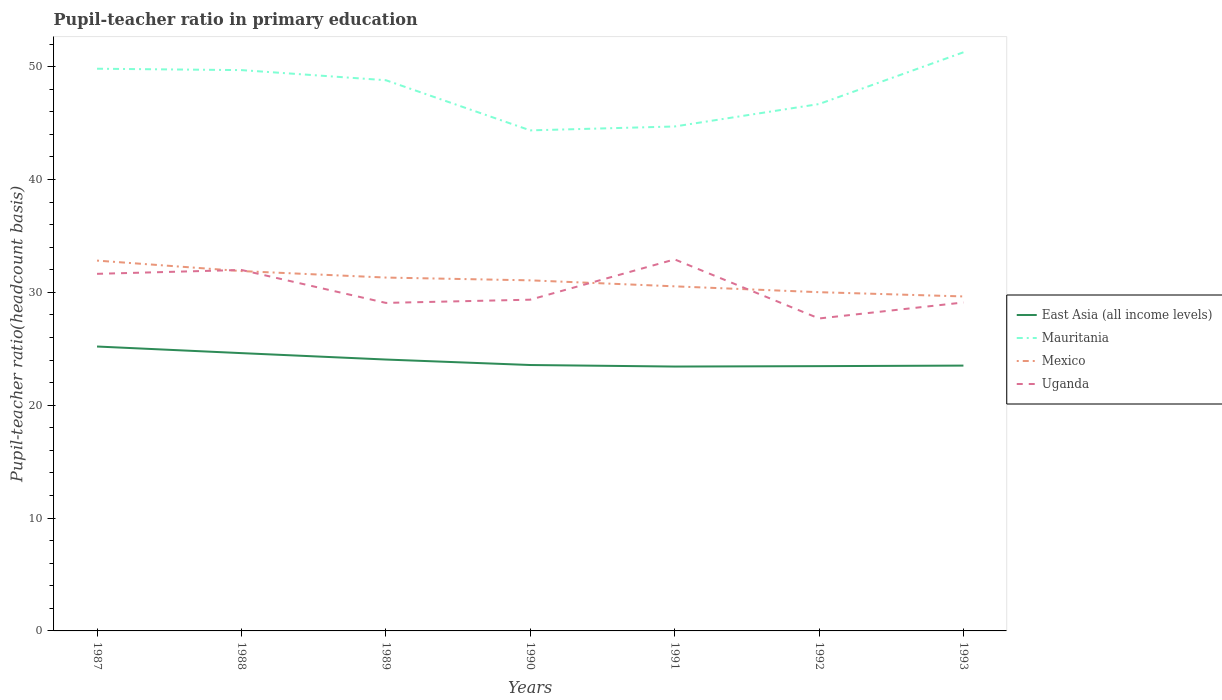How many different coloured lines are there?
Ensure brevity in your answer.  4. Is the number of lines equal to the number of legend labels?
Ensure brevity in your answer.  Yes. Across all years, what is the maximum pupil-teacher ratio in primary education in Mexico?
Provide a short and direct response. 29.64. In which year was the pupil-teacher ratio in primary education in Mexico maximum?
Your response must be concise. 1993. What is the total pupil-teacher ratio in primary education in East Asia (all income levels) in the graph?
Offer a terse response. -0.05. What is the difference between the highest and the second highest pupil-teacher ratio in primary education in Uganda?
Provide a short and direct response. 5.24. Is the pupil-teacher ratio in primary education in Uganda strictly greater than the pupil-teacher ratio in primary education in Mexico over the years?
Ensure brevity in your answer.  No. How many lines are there?
Give a very brief answer. 4. What is the difference between two consecutive major ticks on the Y-axis?
Your answer should be compact. 10. Does the graph contain grids?
Your answer should be compact. No. Where does the legend appear in the graph?
Your answer should be very brief. Center right. What is the title of the graph?
Offer a very short reply. Pupil-teacher ratio in primary education. Does "Bahamas" appear as one of the legend labels in the graph?
Offer a very short reply. No. What is the label or title of the Y-axis?
Your answer should be compact. Pupil-teacher ratio(headcount basis). What is the Pupil-teacher ratio(headcount basis) in East Asia (all income levels) in 1987?
Your answer should be compact. 25.2. What is the Pupil-teacher ratio(headcount basis) in Mauritania in 1987?
Offer a terse response. 49.82. What is the Pupil-teacher ratio(headcount basis) of Mexico in 1987?
Provide a short and direct response. 32.82. What is the Pupil-teacher ratio(headcount basis) of Uganda in 1987?
Offer a very short reply. 31.64. What is the Pupil-teacher ratio(headcount basis) in East Asia (all income levels) in 1988?
Your answer should be very brief. 24.62. What is the Pupil-teacher ratio(headcount basis) of Mauritania in 1988?
Your answer should be compact. 49.7. What is the Pupil-teacher ratio(headcount basis) of Mexico in 1988?
Keep it short and to the point. 31.89. What is the Pupil-teacher ratio(headcount basis) in Uganda in 1988?
Your response must be concise. 31.99. What is the Pupil-teacher ratio(headcount basis) of East Asia (all income levels) in 1989?
Provide a succinct answer. 24.05. What is the Pupil-teacher ratio(headcount basis) in Mauritania in 1989?
Keep it short and to the point. 48.8. What is the Pupil-teacher ratio(headcount basis) of Mexico in 1989?
Make the answer very short. 31.31. What is the Pupil-teacher ratio(headcount basis) in Uganda in 1989?
Give a very brief answer. 29.07. What is the Pupil-teacher ratio(headcount basis) in East Asia (all income levels) in 1990?
Your answer should be compact. 23.56. What is the Pupil-teacher ratio(headcount basis) in Mauritania in 1990?
Your response must be concise. 44.36. What is the Pupil-teacher ratio(headcount basis) in Mexico in 1990?
Offer a very short reply. 31.07. What is the Pupil-teacher ratio(headcount basis) of Uganda in 1990?
Your answer should be very brief. 29.35. What is the Pupil-teacher ratio(headcount basis) in East Asia (all income levels) in 1991?
Offer a very short reply. 23.43. What is the Pupil-teacher ratio(headcount basis) of Mauritania in 1991?
Your response must be concise. 44.7. What is the Pupil-teacher ratio(headcount basis) in Mexico in 1991?
Provide a succinct answer. 30.54. What is the Pupil-teacher ratio(headcount basis) of Uganda in 1991?
Your response must be concise. 32.92. What is the Pupil-teacher ratio(headcount basis) of East Asia (all income levels) in 1992?
Offer a terse response. 23.46. What is the Pupil-teacher ratio(headcount basis) of Mauritania in 1992?
Your answer should be compact. 46.69. What is the Pupil-teacher ratio(headcount basis) of Mexico in 1992?
Offer a very short reply. 30.02. What is the Pupil-teacher ratio(headcount basis) of Uganda in 1992?
Your response must be concise. 27.69. What is the Pupil-teacher ratio(headcount basis) of East Asia (all income levels) in 1993?
Ensure brevity in your answer.  23.51. What is the Pupil-teacher ratio(headcount basis) in Mauritania in 1993?
Offer a very short reply. 51.28. What is the Pupil-teacher ratio(headcount basis) in Mexico in 1993?
Offer a very short reply. 29.64. What is the Pupil-teacher ratio(headcount basis) of Uganda in 1993?
Keep it short and to the point. 29.11. Across all years, what is the maximum Pupil-teacher ratio(headcount basis) in East Asia (all income levels)?
Offer a terse response. 25.2. Across all years, what is the maximum Pupil-teacher ratio(headcount basis) of Mauritania?
Your response must be concise. 51.28. Across all years, what is the maximum Pupil-teacher ratio(headcount basis) in Mexico?
Give a very brief answer. 32.82. Across all years, what is the maximum Pupil-teacher ratio(headcount basis) in Uganda?
Your answer should be very brief. 32.92. Across all years, what is the minimum Pupil-teacher ratio(headcount basis) in East Asia (all income levels)?
Give a very brief answer. 23.43. Across all years, what is the minimum Pupil-teacher ratio(headcount basis) in Mauritania?
Ensure brevity in your answer.  44.36. Across all years, what is the minimum Pupil-teacher ratio(headcount basis) in Mexico?
Make the answer very short. 29.64. Across all years, what is the minimum Pupil-teacher ratio(headcount basis) of Uganda?
Your answer should be compact. 27.69. What is the total Pupil-teacher ratio(headcount basis) in East Asia (all income levels) in the graph?
Your answer should be compact. 167.84. What is the total Pupil-teacher ratio(headcount basis) in Mauritania in the graph?
Give a very brief answer. 335.34. What is the total Pupil-teacher ratio(headcount basis) in Mexico in the graph?
Offer a very short reply. 217.28. What is the total Pupil-teacher ratio(headcount basis) in Uganda in the graph?
Give a very brief answer. 211.77. What is the difference between the Pupil-teacher ratio(headcount basis) in East Asia (all income levels) in 1987 and that in 1988?
Ensure brevity in your answer.  0.59. What is the difference between the Pupil-teacher ratio(headcount basis) of Mauritania in 1987 and that in 1988?
Make the answer very short. 0.12. What is the difference between the Pupil-teacher ratio(headcount basis) in Mexico in 1987 and that in 1988?
Provide a short and direct response. 0.93. What is the difference between the Pupil-teacher ratio(headcount basis) of Uganda in 1987 and that in 1988?
Your response must be concise. -0.34. What is the difference between the Pupil-teacher ratio(headcount basis) in East Asia (all income levels) in 1987 and that in 1989?
Offer a very short reply. 1.15. What is the difference between the Pupil-teacher ratio(headcount basis) of Mauritania in 1987 and that in 1989?
Make the answer very short. 1.02. What is the difference between the Pupil-teacher ratio(headcount basis) in Mexico in 1987 and that in 1989?
Offer a very short reply. 1.5. What is the difference between the Pupil-teacher ratio(headcount basis) in Uganda in 1987 and that in 1989?
Provide a succinct answer. 2.58. What is the difference between the Pupil-teacher ratio(headcount basis) in East Asia (all income levels) in 1987 and that in 1990?
Offer a very short reply. 1.64. What is the difference between the Pupil-teacher ratio(headcount basis) in Mauritania in 1987 and that in 1990?
Your answer should be very brief. 5.46. What is the difference between the Pupil-teacher ratio(headcount basis) in Mexico in 1987 and that in 1990?
Provide a short and direct response. 1.75. What is the difference between the Pupil-teacher ratio(headcount basis) in Uganda in 1987 and that in 1990?
Offer a terse response. 2.29. What is the difference between the Pupil-teacher ratio(headcount basis) in East Asia (all income levels) in 1987 and that in 1991?
Your response must be concise. 1.77. What is the difference between the Pupil-teacher ratio(headcount basis) of Mauritania in 1987 and that in 1991?
Offer a terse response. 5.12. What is the difference between the Pupil-teacher ratio(headcount basis) in Mexico in 1987 and that in 1991?
Your answer should be very brief. 2.28. What is the difference between the Pupil-teacher ratio(headcount basis) of Uganda in 1987 and that in 1991?
Offer a terse response. -1.28. What is the difference between the Pupil-teacher ratio(headcount basis) in East Asia (all income levels) in 1987 and that in 1992?
Offer a very short reply. 1.74. What is the difference between the Pupil-teacher ratio(headcount basis) of Mauritania in 1987 and that in 1992?
Ensure brevity in your answer.  3.13. What is the difference between the Pupil-teacher ratio(headcount basis) in Mexico in 1987 and that in 1992?
Your answer should be very brief. 2.8. What is the difference between the Pupil-teacher ratio(headcount basis) of Uganda in 1987 and that in 1992?
Make the answer very short. 3.96. What is the difference between the Pupil-teacher ratio(headcount basis) of East Asia (all income levels) in 1987 and that in 1993?
Offer a very short reply. 1.69. What is the difference between the Pupil-teacher ratio(headcount basis) in Mauritania in 1987 and that in 1993?
Keep it short and to the point. -1.46. What is the difference between the Pupil-teacher ratio(headcount basis) of Mexico in 1987 and that in 1993?
Give a very brief answer. 3.18. What is the difference between the Pupil-teacher ratio(headcount basis) of Uganda in 1987 and that in 1993?
Ensure brevity in your answer.  2.54. What is the difference between the Pupil-teacher ratio(headcount basis) of East Asia (all income levels) in 1988 and that in 1989?
Give a very brief answer. 0.57. What is the difference between the Pupil-teacher ratio(headcount basis) in Mauritania in 1988 and that in 1989?
Offer a terse response. 0.9. What is the difference between the Pupil-teacher ratio(headcount basis) in Mexico in 1988 and that in 1989?
Your response must be concise. 0.57. What is the difference between the Pupil-teacher ratio(headcount basis) in Uganda in 1988 and that in 1989?
Ensure brevity in your answer.  2.92. What is the difference between the Pupil-teacher ratio(headcount basis) of East Asia (all income levels) in 1988 and that in 1990?
Offer a very short reply. 1.05. What is the difference between the Pupil-teacher ratio(headcount basis) in Mauritania in 1988 and that in 1990?
Provide a succinct answer. 5.34. What is the difference between the Pupil-teacher ratio(headcount basis) of Mexico in 1988 and that in 1990?
Keep it short and to the point. 0.82. What is the difference between the Pupil-teacher ratio(headcount basis) in Uganda in 1988 and that in 1990?
Provide a short and direct response. 2.63. What is the difference between the Pupil-teacher ratio(headcount basis) of East Asia (all income levels) in 1988 and that in 1991?
Offer a very short reply. 1.19. What is the difference between the Pupil-teacher ratio(headcount basis) of Mauritania in 1988 and that in 1991?
Offer a very short reply. 5. What is the difference between the Pupil-teacher ratio(headcount basis) of Mexico in 1988 and that in 1991?
Make the answer very short. 1.35. What is the difference between the Pupil-teacher ratio(headcount basis) in Uganda in 1988 and that in 1991?
Your answer should be very brief. -0.94. What is the difference between the Pupil-teacher ratio(headcount basis) in East Asia (all income levels) in 1988 and that in 1992?
Ensure brevity in your answer.  1.15. What is the difference between the Pupil-teacher ratio(headcount basis) of Mauritania in 1988 and that in 1992?
Make the answer very short. 3.01. What is the difference between the Pupil-teacher ratio(headcount basis) of Mexico in 1988 and that in 1992?
Your response must be concise. 1.87. What is the difference between the Pupil-teacher ratio(headcount basis) in East Asia (all income levels) in 1988 and that in 1993?
Your response must be concise. 1.11. What is the difference between the Pupil-teacher ratio(headcount basis) in Mauritania in 1988 and that in 1993?
Your answer should be very brief. -1.58. What is the difference between the Pupil-teacher ratio(headcount basis) of Mexico in 1988 and that in 1993?
Keep it short and to the point. 2.25. What is the difference between the Pupil-teacher ratio(headcount basis) in Uganda in 1988 and that in 1993?
Keep it short and to the point. 2.88. What is the difference between the Pupil-teacher ratio(headcount basis) in East Asia (all income levels) in 1989 and that in 1990?
Give a very brief answer. 0.49. What is the difference between the Pupil-teacher ratio(headcount basis) in Mauritania in 1989 and that in 1990?
Provide a short and direct response. 4.44. What is the difference between the Pupil-teacher ratio(headcount basis) in Mexico in 1989 and that in 1990?
Your answer should be compact. 0.25. What is the difference between the Pupil-teacher ratio(headcount basis) of Uganda in 1989 and that in 1990?
Make the answer very short. -0.28. What is the difference between the Pupil-teacher ratio(headcount basis) in East Asia (all income levels) in 1989 and that in 1991?
Your answer should be compact. 0.62. What is the difference between the Pupil-teacher ratio(headcount basis) of Mauritania in 1989 and that in 1991?
Offer a terse response. 4.1. What is the difference between the Pupil-teacher ratio(headcount basis) of Mexico in 1989 and that in 1991?
Your answer should be compact. 0.78. What is the difference between the Pupil-teacher ratio(headcount basis) of Uganda in 1989 and that in 1991?
Provide a short and direct response. -3.86. What is the difference between the Pupil-teacher ratio(headcount basis) of East Asia (all income levels) in 1989 and that in 1992?
Make the answer very short. 0.59. What is the difference between the Pupil-teacher ratio(headcount basis) in Mauritania in 1989 and that in 1992?
Offer a very short reply. 2.11. What is the difference between the Pupil-teacher ratio(headcount basis) of Mexico in 1989 and that in 1992?
Provide a short and direct response. 1.3. What is the difference between the Pupil-teacher ratio(headcount basis) of Uganda in 1989 and that in 1992?
Make the answer very short. 1.38. What is the difference between the Pupil-teacher ratio(headcount basis) of East Asia (all income levels) in 1989 and that in 1993?
Keep it short and to the point. 0.54. What is the difference between the Pupil-teacher ratio(headcount basis) of Mauritania in 1989 and that in 1993?
Provide a succinct answer. -2.47. What is the difference between the Pupil-teacher ratio(headcount basis) in Mexico in 1989 and that in 1993?
Make the answer very short. 1.67. What is the difference between the Pupil-teacher ratio(headcount basis) in Uganda in 1989 and that in 1993?
Ensure brevity in your answer.  -0.04. What is the difference between the Pupil-teacher ratio(headcount basis) in East Asia (all income levels) in 1990 and that in 1991?
Your response must be concise. 0.14. What is the difference between the Pupil-teacher ratio(headcount basis) of Mauritania in 1990 and that in 1991?
Offer a very short reply. -0.34. What is the difference between the Pupil-teacher ratio(headcount basis) of Mexico in 1990 and that in 1991?
Your answer should be very brief. 0.53. What is the difference between the Pupil-teacher ratio(headcount basis) of Uganda in 1990 and that in 1991?
Give a very brief answer. -3.57. What is the difference between the Pupil-teacher ratio(headcount basis) of East Asia (all income levels) in 1990 and that in 1992?
Make the answer very short. 0.1. What is the difference between the Pupil-teacher ratio(headcount basis) of Mauritania in 1990 and that in 1992?
Ensure brevity in your answer.  -2.33. What is the difference between the Pupil-teacher ratio(headcount basis) in Mexico in 1990 and that in 1992?
Provide a succinct answer. 1.05. What is the difference between the Pupil-teacher ratio(headcount basis) of Uganda in 1990 and that in 1992?
Ensure brevity in your answer.  1.67. What is the difference between the Pupil-teacher ratio(headcount basis) in East Asia (all income levels) in 1990 and that in 1993?
Provide a succinct answer. 0.05. What is the difference between the Pupil-teacher ratio(headcount basis) of Mauritania in 1990 and that in 1993?
Offer a terse response. -6.92. What is the difference between the Pupil-teacher ratio(headcount basis) in Mexico in 1990 and that in 1993?
Provide a short and direct response. 1.43. What is the difference between the Pupil-teacher ratio(headcount basis) of Uganda in 1990 and that in 1993?
Your answer should be very brief. 0.25. What is the difference between the Pupil-teacher ratio(headcount basis) in East Asia (all income levels) in 1991 and that in 1992?
Keep it short and to the point. -0.04. What is the difference between the Pupil-teacher ratio(headcount basis) of Mauritania in 1991 and that in 1992?
Your response must be concise. -1.99. What is the difference between the Pupil-teacher ratio(headcount basis) of Mexico in 1991 and that in 1992?
Your response must be concise. 0.52. What is the difference between the Pupil-teacher ratio(headcount basis) in Uganda in 1991 and that in 1992?
Make the answer very short. 5.24. What is the difference between the Pupil-teacher ratio(headcount basis) of East Asia (all income levels) in 1991 and that in 1993?
Make the answer very short. -0.08. What is the difference between the Pupil-teacher ratio(headcount basis) in Mauritania in 1991 and that in 1993?
Make the answer very short. -6.57. What is the difference between the Pupil-teacher ratio(headcount basis) of Mexico in 1991 and that in 1993?
Your answer should be very brief. 0.9. What is the difference between the Pupil-teacher ratio(headcount basis) of Uganda in 1991 and that in 1993?
Your answer should be very brief. 3.82. What is the difference between the Pupil-teacher ratio(headcount basis) in East Asia (all income levels) in 1992 and that in 1993?
Offer a very short reply. -0.05. What is the difference between the Pupil-teacher ratio(headcount basis) of Mauritania in 1992 and that in 1993?
Make the answer very short. -4.59. What is the difference between the Pupil-teacher ratio(headcount basis) in Mexico in 1992 and that in 1993?
Make the answer very short. 0.38. What is the difference between the Pupil-teacher ratio(headcount basis) in Uganda in 1992 and that in 1993?
Your answer should be compact. -1.42. What is the difference between the Pupil-teacher ratio(headcount basis) in East Asia (all income levels) in 1987 and the Pupil-teacher ratio(headcount basis) in Mauritania in 1988?
Make the answer very short. -24.49. What is the difference between the Pupil-teacher ratio(headcount basis) of East Asia (all income levels) in 1987 and the Pupil-teacher ratio(headcount basis) of Mexico in 1988?
Your answer should be very brief. -6.69. What is the difference between the Pupil-teacher ratio(headcount basis) of East Asia (all income levels) in 1987 and the Pupil-teacher ratio(headcount basis) of Uganda in 1988?
Your answer should be very brief. -6.78. What is the difference between the Pupil-teacher ratio(headcount basis) in Mauritania in 1987 and the Pupil-teacher ratio(headcount basis) in Mexico in 1988?
Make the answer very short. 17.93. What is the difference between the Pupil-teacher ratio(headcount basis) in Mauritania in 1987 and the Pupil-teacher ratio(headcount basis) in Uganda in 1988?
Offer a very short reply. 17.83. What is the difference between the Pupil-teacher ratio(headcount basis) in Mexico in 1987 and the Pupil-teacher ratio(headcount basis) in Uganda in 1988?
Provide a succinct answer. 0.83. What is the difference between the Pupil-teacher ratio(headcount basis) of East Asia (all income levels) in 1987 and the Pupil-teacher ratio(headcount basis) of Mauritania in 1989?
Provide a short and direct response. -23.6. What is the difference between the Pupil-teacher ratio(headcount basis) of East Asia (all income levels) in 1987 and the Pupil-teacher ratio(headcount basis) of Mexico in 1989?
Provide a succinct answer. -6.11. What is the difference between the Pupil-teacher ratio(headcount basis) in East Asia (all income levels) in 1987 and the Pupil-teacher ratio(headcount basis) in Uganda in 1989?
Provide a succinct answer. -3.87. What is the difference between the Pupil-teacher ratio(headcount basis) of Mauritania in 1987 and the Pupil-teacher ratio(headcount basis) of Mexico in 1989?
Make the answer very short. 18.51. What is the difference between the Pupil-teacher ratio(headcount basis) in Mauritania in 1987 and the Pupil-teacher ratio(headcount basis) in Uganda in 1989?
Offer a very short reply. 20.75. What is the difference between the Pupil-teacher ratio(headcount basis) in Mexico in 1987 and the Pupil-teacher ratio(headcount basis) in Uganda in 1989?
Offer a very short reply. 3.75. What is the difference between the Pupil-teacher ratio(headcount basis) in East Asia (all income levels) in 1987 and the Pupil-teacher ratio(headcount basis) in Mauritania in 1990?
Keep it short and to the point. -19.15. What is the difference between the Pupil-teacher ratio(headcount basis) of East Asia (all income levels) in 1987 and the Pupil-teacher ratio(headcount basis) of Mexico in 1990?
Your answer should be very brief. -5.86. What is the difference between the Pupil-teacher ratio(headcount basis) in East Asia (all income levels) in 1987 and the Pupil-teacher ratio(headcount basis) in Uganda in 1990?
Provide a short and direct response. -4.15. What is the difference between the Pupil-teacher ratio(headcount basis) in Mauritania in 1987 and the Pupil-teacher ratio(headcount basis) in Mexico in 1990?
Make the answer very short. 18.75. What is the difference between the Pupil-teacher ratio(headcount basis) in Mauritania in 1987 and the Pupil-teacher ratio(headcount basis) in Uganda in 1990?
Provide a succinct answer. 20.47. What is the difference between the Pupil-teacher ratio(headcount basis) in Mexico in 1987 and the Pupil-teacher ratio(headcount basis) in Uganda in 1990?
Keep it short and to the point. 3.46. What is the difference between the Pupil-teacher ratio(headcount basis) of East Asia (all income levels) in 1987 and the Pupil-teacher ratio(headcount basis) of Mauritania in 1991?
Offer a very short reply. -19.5. What is the difference between the Pupil-teacher ratio(headcount basis) of East Asia (all income levels) in 1987 and the Pupil-teacher ratio(headcount basis) of Mexico in 1991?
Your response must be concise. -5.33. What is the difference between the Pupil-teacher ratio(headcount basis) in East Asia (all income levels) in 1987 and the Pupil-teacher ratio(headcount basis) in Uganda in 1991?
Give a very brief answer. -7.72. What is the difference between the Pupil-teacher ratio(headcount basis) of Mauritania in 1987 and the Pupil-teacher ratio(headcount basis) of Mexico in 1991?
Your response must be concise. 19.28. What is the difference between the Pupil-teacher ratio(headcount basis) of Mauritania in 1987 and the Pupil-teacher ratio(headcount basis) of Uganda in 1991?
Your answer should be very brief. 16.9. What is the difference between the Pupil-teacher ratio(headcount basis) of Mexico in 1987 and the Pupil-teacher ratio(headcount basis) of Uganda in 1991?
Give a very brief answer. -0.11. What is the difference between the Pupil-teacher ratio(headcount basis) of East Asia (all income levels) in 1987 and the Pupil-teacher ratio(headcount basis) of Mauritania in 1992?
Your answer should be very brief. -21.49. What is the difference between the Pupil-teacher ratio(headcount basis) in East Asia (all income levels) in 1987 and the Pupil-teacher ratio(headcount basis) in Mexico in 1992?
Your answer should be compact. -4.81. What is the difference between the Pupil-teacher ratio(headcount basis) in East Asia (all income levels) in 1987 and the Pupil-teacher ratio(headcount basis) in Uganda in 1992?
Provide a succinct answer. -2.48. What is the difference between the Pupil-teacher ratio(headcount basis) in Mauritania in 1987 and the Pupil-teacher ratio(headcount basis) in Mexico in 1992?
Offer a terse response. 19.8. What is the difference between the Pupil-teacher ratio(headcount basis) in Mauritania in 1987 and the Pupil-teacher ratio(headcount basis) in Uganda in 1992?
Offer a very short reply. 22.13. What is the difference between the Pupil-teacher ratio(headcount basis) of Mexico in 1987 and the Pupil-teacher ratio(headcount basis) of Uganda in 1992?
Ensure brevity in your answer.  5.13. What is the difference between the Pupil-teacher ratio(headcount basis) in East Asia (all income levels) in 1987 and the Pupil-teacher ratio(headcount basis) in Mauritania in 1993?
Provide a short and direct response. -26.07. What is the difference between the Pupil-teacher ratio(headcount basis) of East Asia (all income levels) in 1987 and the Pupil-teacher ratio(headcount basis) of Mexico in 1993?
Ensure brevity in your answer.  -4.44. What is the difference between the Pupil-teacher ratio(headcount basis) in East Asia (all income levels) in 1987 and the Pupil-teacher ratio(headcount basis) in Uganda in 1993?
Your answer should be compact. -3.9. What is the difference between the Pupil-teacher ratio(headcount basis) of Mauritania in 1987 and the Pupil-teacher ratio(headcount basis) of Mexico in 1993?
Your answer should be very brief. 20.18. What is the difference between the Pupil-teacher ratio(headcount basis) of Mauritania in 1987 and the Pupil-teacher ratio(headcount basis) of Uganda in 1993?
Your answer should be compact. 20.71. What is the difference between the Pupil-teacher ratio(headcount basis) in Mexico in 1987 and the Pupil-teacher ratio(headcount basis) in Uganda in 1993?
Offer a very short reply. 3.71. What is the difference between the Pupil-teacher ratio(headcount basis) in East Asia (all income levels) in 1988 and the Pupil-teacher ratio(headcount basis) in Mauritania in 1989?
Your answer should be very brief. -24.18. What is the difference between the Pupil-teacher ratio(headcount basis) of East Asia (all income levels) in 1988 and the Pupil-teacher ratio(headcount basis) of Mexico in 1989?
Offer a very short reply. -6.7. What is the difference between the Pupil-teacher ratio(headcount basis) in East Asia (all income levels) in 1988 and the Pupil-teacher ratio(headcount basis) in Uganda in 1989?
Offer a very short reply. -4.45. What is the difference between the Pupil-teacher ratio(headcount basis) in Mauritania in 1988 and the Pupil-teacher ratio(headcount basis) in Mexico in 1989?
Keep it short and to the point. 18.38. What is the difference between the Pupil-teacher ratio(headcount basis) of Mauritania in 1988 and the Pupil-teacher ratio(headcount basis) of Uganda in 1989?
Keep it short and to the point. 20.63. What is the difference between the Pupil-teacher ratio(headcount basis) of Mexico in 1988 and the Pupil-teacher ratio(headcount basis) of Uganda in 1989?
Your answer should be very brief. 2.82. What is the difference between the Pupil-teacher ratio(headcount basis) in East Asia (all income levels) in 1988 and the Pupil-teacher ratio(headcount basis) in Mauritania in 1990?
Make the answer very short. -19.74. What is the difference between the Pupil-teacher ratio(headcount basis) in East Asia (all income levels) in 1988 and the Pupil-teacher ratio(headcount basis) in Mexico in 1990?
Give a very brief answer. -6.45. What is the difference between the Pupil-teacher ratio(headcount basis) of East Asia (all income levels) in 1988 and the Pupil-teacher ratio(headcount basis) of Uganda in 1990?
Keep it short and to the point. -4.74. What is the difference between the Pupil-teacher ratio(headcount basis) of Mauritania in 1988 and the Pupil-teacher ratio(headcount basis) of Mexico in 1990?
Make the answer very short. 18.63. What is the difference between the Pupil-teacher ratio(headcount basis) of Mauritania in 1988 and the Pupil-teacher ratio(headcount basis) of Uganda in 1990?
Offer a very short reply. 20.34. What is the difference between the Pupil-teacher ratio(headcount basis) in Mexico in 1988 and the Pupil-teacher ratio(headcount basis) in Uganda in 1990?
Your answer should be compact. 2.54. What is the difference between the Pupil-teacher ratio(headcount basis) of East Asia (all income levels) in 1988 and the Pupil-teacher ratio(headcount basis) of Mauritania in 1991?
Your answer should be very brief. -20.08. What is the difference between the Pupil-teacher ratio(headcount basis) of East Asia (all income levels) in 1988 and the Pupil-teacher ratio(headcount basis) of Mexico in 1991?
Your answer should be compact. -5.92. What is the difference between the Pupil-teacher ratio(headcount basis) in East Asia (all income levels) in 1988 and the Pupil-teacher ratio(headcount basis) in Uganda in 1991?
Provide a succinct answer. -8.31. What is the difference between the Pupil-teacher ratio(headcount basis) in Mauritania in 1988 and the Pupil-teacher ratio(headcount basis) in Mexico in 1991?
Your answer should be compact. 19.16. What is the difference between the Pupil-teacher ratio(headcount basis) of Mauritania in 1988 and the Pupil-teacher ratio(headcount basis) of Uganda in 1991?
Your answer should be very brief. 16.77. What is the difference between the Pupil-teacher ratio(headcount basis) of Mexico in 1988 and the Pupil-teacher ratio(headcount basis) of Uganda in 1991?
Your answer should be compact. -1.03. What is the difference between the Pupil-teacher ratio(headcount basis) of East Asia (all income levels) in 1988 and the Pupil-teacher ratio(headcount basis) of Mauritania in 1992?
Give a very brief answer. -22.07. What is the difference between the Pupil-teacher ratio(headcount basis) of East Asia (all income levels) in 1988 and the Pupil-teacher ratio(headcount basis) of Mexico in 1992?
Offer a very short reply. -5.4. What is the difference between the Pupil-teacher ratio(headcount basis) in East Asia (all income levels) in 1988 and the Pupil-teacher ratio(headcount basis) in Uganda in 1992?
Make the answer very short. -3.07. What is the difference between the Pupil-teacher ratio(headcount basis) of Mauritania in 1988 and the Pupil-teacher ratio(headcount basis) of Mexico in 1992?
Provide a short and direct response. 19.68. What is the difference between the Pupil-teacher ratio(headcount basis) in Mauritania in 1988 and the Pupil-teacher ratio(headcount basis) in Uganda in 1992?
Offer a very short reply. 22.01. What is the difference between the Pupil-teacher ratio(headcount basis) in Mexico in 1988 and the Pupil-teacher ratio(headcount basis) in Uganda in 1992?
Your response must be concise. 4.2. What is the difference between the Pupil-teacher ratio(headcount basis) of East Asia (all income levels) in 1988 and the Pupil-teacher ratio(headcount basis) of Mauritania in 1993?
Provide a succinct answer. -26.66. What is the difference between the Pupil-teacher ratio(headcount basis) in East Asia (all income levels) in 1988 and the Pupil-teacher ratio(headcount basis) in Mexico in 1993?
Offer a very short reply. -5.02. What is the difference between the Pupil-teacher ratio(headcount basis) in East Asia (all income levels) in 1988 and the Pupil-teacher ratio(headcount basis) in Uganda in 1993?
Your answer should be very brief. -4.49. What is the difference between the Pupil-teacher ratio(headcount basis) of Mauritania in 1988 and the Pupil-teacher ratio(headcount basis) of Mexico in 1993?
Ensure brevity in your answer.  20.06. What is the difference between the Pupil-teacher ratio(headcount basis) in Mauritania in 1988 and the Pupil-teacher ratio(headcount basis) in Uganda in 1993?
Your answer should be very brief. 20.59. What is the difference between the Pupil-teacher ratio(headcount basis) of Mexico in 1988 and the Pupil-teacher ratio(headcount basis) of Uganda in 1993?
Give a very brief answer. 2.78. What is the difference between the Pupil-teacher ratio(headcount basis) of East Asia (all income levels) in 1989 and the Pupil-teacher ratio(headcount basis) of Mauritania in 1990?
Give a very brief answer. -20.31. What is the difference between the Pupil-teacher ratio(headcount basis) of East Asia (all income levels) in 1989 and the Pupil-teacher ratio(headcount basis) of Mexico in 1990?
Offer a very short reply. -7.02. What is the difference between the Pupil-teacher ratio(headcount basis) of East Asia (all income levels) in 1989 and the Pupil-teacher ratio(headcount basis) of Uganda in 1990?
Your response must be concise. -5.3. What is the difference between the Pupil-teacher ratio(headcount basis) in Mauritania in 1989 and the Pupil-teacher ratio(headcount basis) in Mexico in 1990?
Your answer should be very brief. 17.73. What is the difference between the Pupil-teacher ratio(headcount basis) in Mauritania in 1989 and the Pupil-teacher ratio(headcount basis) in Uganda in 1990?
Keep it short and to the point. 19.45. What is the difference between the Pupil-teacher ratio(headcount basis) of Mexico in 1989 and the Pupil-teacher ratio(headcount basis) of Uganda in 1990?
Your answer should be very brief. 1.96. What is the difference between the Pupil-teacher ratio(headcount basis) of East Asia (all income levels) in 1989 and the Pupil-teacher ratio(headcount basis) of Mauritania in 1991?
Keep it short and to the point. -20.65. What is the difference between the Pupil-teacher ratio(headcount basis) of East Asia (all income levels) in 1989 and the Pupil-teacher ratio(headcount basis) of Mexico in 1991?
Keep it short and to the point. -6.49. What is the difference between the Pupil-teacher ratio(headcount basis) in East Asia (all income levels) in 1989 and the Pupil-teacher ratio(headcount basis) in Uganda in 1991?
Keep it short and to the point. -8.87. What is the difference between the Pupil-teacher ratio(headcount basis) of Mauritania in 1989 and the Pupil-teacher ratio(headcount basis) of Mexico in 1991?
Give a very brief answer. 18.27. What is the difference between the Pupil-teacher ratio(headcount basis) of Mauritania in 1989 and the Pupil-teacher ratio(headcount basis) of Uganda in 1991?
Your answer should be very brief. 15.88. What is the difference between the Pupil-teacher ratio(headcount basis) of Mexico in 1989 and the Pupil-teacher ratio(headcount basis) of Uganda in 1991?
Keep it short and to the point. -1.61. What is the difference between the Pupil-teacher ratio(headcount basis) in East Asia (all income levels) in 1989 and the Pupil-teacher ratio(headcount basis) in Mauritania in 1992?
Make the answer very short. -22.64. What is the difference between the Pupil-teacher ratio(headcount basis) of East Asia (all income levels) in 1989 and the Pupil-teacher ratio(headcount basis) of Mexico in 1992?
Give a very brief answer. -5.97. What is the difference between the Pupil-teacher ratio(headcount basis) in East Asia (all income levels) in 1989 and the Pupil-teacher ratio(headcount basis) in Uganda in 1992?
Give a very brief answer. -3.64. What is the difference between the Pupil-teacher ratio(headcount basis) in Mauritania in 1989 and the Pupil-teacher ratio(headcount basis) in Mexico in 1992?
Your answer should be compact. 18.78. What is the difference between the Pupil-teacher ratio(headcount basis) in Mauritania in 1989 and the Pupil-teacher ratio(headcount basis) in Uganda in 1992?
Provide a succinct answer. 21.11. What is the difference between the Pupil-teacher ratio(headcount basis) in Mexico in 1989 and the Pupil-teacher ratio(headcount basis) in Uganda in 1992?
Your response must be concise. 3.63. What is the difference between the Pupil-teacher ratio(headcount basis) in East Asia (all income levels) in 1989 and the Pupil-teacher ratio(headcount basis) in Mauritania in 1993?
Your answer should be very brief. -27.23. What is the difference between the Pupil-teacher ratio(headcount basis) of East Asia (all income levels) in 1989 and the Pupil-teacher ratio(headcount basis) of Mexico in 1993?
Keep it short and to the point. -5.59. What is the difference between the Pupil-teacher ratio(headcount basis) in East Asia (all income levels) in 1989 and the Pupil-teacher ratio(headcount basis) in Uganda in 1993?
Keep it short and to the point. -5.06. What is the difference between the Pupil-teacher ratio(headcount basis) of Mauritania in 1989 and the Pupil-teacher ratio(headcount basis) of Mexico in 1993?
Ensure brevity in your answer.  19.16. What is the difference between the Pupil-teacher ratio(headcount basis) of Mauritania in 1989 and the Pupil-teacher ratio(headcount basis) of Uganda in 1993?
Ensure brevity in your answer.  19.7. What is the difference between the Pupil-teacher ratio(headcount basis) in Mexico in 1989 and the Pupil-teacher ratio(headcount basis) in Uganda in 1993?
Offer a terse response. 2.21. What is the difference between the Pupil-teacher ratio(headcount basis) of East Asia (all income levels) in 1990 and the Pupil-teacher ratio(headcount basis) of Mauritania in 1991?
Give a very brief answer. -21.14. What is the difference between the Pupil-teacher ratio(headcount basis) in East Asia (all income levels) in 1990 and the Pupil-teacher ratio(headcount basis) in Mexico in 1991?
Your answer should be very brief. -6.97. What is the difference between the Pupil-teacher ratio(headcount basis) of East Asia (all income levels) in 1990 and the Pupil-teacher ratio(headcount basis) of Uganda in 1991?
Your answer should be very brief. -9.36. What is the difference between the Pupil-teacher ratio(headcount basis) of Mauritania in 1990 and the Pupil-teacher ratio(headcount basis) of Mexico in 1991?
Keep it short and to the point. 13.82. What is the difference between the Pupil-teacher ratio(headcount basis) in Mauritania in 1990 and the Pupil-teacher ratio(headcount basis) in Uganda in 1991?
Your answer should be very brief. 11.43. What is the difference between the Pupil-teacher ratio(headcount basis) of Mexico in 1990 and the Pupil-teacher ratio(headcount basis) of Uganda in 1991?
Make the answer very short. -1.86. What is the difference between the Pupil-teacher ratio(headcount basis) of East Asia (all income levels) in 1990 and the Pupil-teacher ratio(headcount basis) of Mauritania in 1992?
Provide a succinct answer. -23.13. What is the difference between the Pupil-teacher ratio(headcount basis) in East Asia (all income levels) in 1990 and the Pupil-teacher ratio(headcount basis) in Mexico in 1992?
Provide a short and direct response. -6.45. What is the difference between the Pupil-teacher ratio(headcount basis) of East Asia (all income levels) in 1990 and the Pupil-teacher ratio(headcount basis) of Uganda in 1992?
Your answer should be very brief. -4.12. What is the difference between the Pupil-teacher ratio(headcount basis) of Mauritania in 1990 and the Pupil-teacher ratio(headcount basis) of Mexico in 1992?
Your answer should be very brief. 14.34. What is the difference between the Pupil-teacher ratio(headcount basis) in Mauritania in 1990 and the Pupil-teacher ratio(headcount basis) in Uganda in 1992?
Offer a very short reply. 16.67. What is the difference between the Pupil-teacher ratio(headcount basis) of Mexico in 1990 and the Pupil-teacher ratio(headcount basis) of Uganda in 1992?
Keep it short and to the point. 3.38. What is the difference between the Pupil-teacher ratio(headcount basis) of East Asia (all income levels) in 1990 and the Pupil-teacher ratio(headcount basis) of Mauritania in 1993?
Provide a succinct answer. -27.71. What is the difference between the Pupil-teacher ratio(headcount basis) of East Asia (all income levels) in 1990 and the Pupil-teacher ratio(headcount basis) of Mexico in 1993?
Your answer should be compact. -6.08. What is the difference between the Pupil-teacher ratio(headcount basis) in East Asia (all income levels) in 1990 and the Pupil-teacher ratio(headcount basis) in Uganda in 1993?
Ensure brevity in your answer.  -5.54. What is the difference between the Pupil-teacher ratio(headcount basis) of Mauritania in 1990 and the Pupil-teacher ratio(headcount basis) of Mexico in 1993?
Provide a succinct answer. 14.72. What is the difference between the Pupil-teacher ratio(headcount basis) of Mauritania in 1990 and the Pupil-teacher ratio(headcount basis) of Uganda in 1993?
Your response must be concise. 15.25. What is the difference between the Pupil-teacher ratio(headcount basis) in Mexico in 1990 and the Pupil-teacher ratio(headcount basis) in Uganda in 1993?
Provide a short and direct response. 1.96. What is the difference between the Pupil-teacher ratio(headcount basis) in East Asia (all income levels) in 1991 and the Pupil-teacher ratio(headcount basis) in Mauritania in 1992?
Keep it short and to the point. -23.26. What is the difference between the Pupil-teacher ratio(headcount basis) of East Asia (all income levels) in 1991 and the Pupil-teacher ratio(headcount basis) of Mexico in 1992?
Your response must be concise. -6.59. What is the difference between the Pupil-teacher ratio(headcount basis) in East Asia (all income levels) in 1991 and the Pupil-teacher ratio(headcount basis) in Uganda in 1992?
Provide a short and direct response. -4.26. What is the difference between the Pupil-teacher ratio(headcount basis) of Mauritania in 1991 and the Pupil-teacher ratio(headcount basis) of Mexico in 1992?
Ensure brevity in your answer.  14.68. What is the difference between the Pupil-teacher ratio(headcount basis) of Mauritania in 1991 and the Pupil-teacher ratio(headcount basis) of Uganda in 1992?
Provide a succinct answer. 17.01. What is the difference between the Pupil-teacher ratio(headcount basis) of Mexico in 1991 and the Pupil-teacher ratio(headcount basis) of Uganda in 1992?
Keep it short and to the point. 2.85. What is the difference between the Pupil-teacher ratio(headcount basis) of East Asia (all income levels) in 1991 and the Pupil-teacher ratio(headcount basis) of Mauritania in 1993?
Your answer should be very brief. -27.85. What is the difference between the Pupil-teacher ratio(headcount basis) of East Asia (all income levels) in 1991 and the Pupil-teacher ratio(headcount basis) of Mexico in 1993?
Your response must be concise. -6.21. What is the difference between the Pupil-teacher ratio(headcount basis) of East Asia (all income levels) in 1991 and the Pupil-teacher ratio(headcount basis) of Uganda in 1993?
Your answer should be compact. -5.68. What is the difference between the Pupil-teacher ratio(headcount basis) of Mauritania in 1991 and the Pupil-teacher ratio(headcount basis) of Mexico in 1993?
Your answer should be compact. 15.06. What is the difference between the Pupil-teacher ratio(headcount basis) in Mauritania in 1991 and the Pupil-teacher ratio(headcount basis) in Uganda in 1993?
Offer a terse response. 15.6. What is the difference between the Pupil-teacher ratio(headcount basis) of Mexico in 1991 and the Pupil-teacher ratio(headcount basis) of Uganda in 1993?
Offer a terse response. 1.43. What is the difference between the Pupil-teacher ratio(headcount basis) of East Asia (all income levels) in 1992 and the Pupil-teacher ratio(headcount basis) of Mauritania in 1993?
Your response must be concise. -27.81. What is the difference between the Pupil-teacher ratio(headcount basis) of East Asia (all income levels) in 1992 and the Pupil-teacher ratio(headcount basis) of Mexico in 1993?
Your answer should be very brief. -6.18. What is the difference between the Pupil-teacher ratio(headcount basis) of East Asia (all income levels) in 1992 and the Pupil-teacher ratio(headcount basis) of Uganda in 1993?
Provide a succinct answer. -5.64. What is the difference between the Pupil-teacher ratio(headcount basis) in Mauritania in 1992 and the Pupil-teacher ratio(headcount basis) in Mexico in 1993?
Your answer should be very brief. 17.05. What is the difference between the Pupil-teacher ratio(headcount basis) in Mauritania in 1992 and the Pupil-teacher ratio(headcount basis) in Uganda in 1993?
Your answer should be very brief. 17.58. What is the difference between the Pupil-teacher ratio(headcount basis) in Mexico in 1992 and the Pupil-teacher ratio(headcount basis) in Uganda in 1993?
Offer a very short reply. 0.91. What is the average Pupil-teacher ratio(headcount basis) in East Asia (all income levels) per year?
Provide a short and direct response. 23.98. What is the average Pupil-teacher ratio(headcount basis) of Mauritania per year?
Ensure brevity in your answer.  47.91. What is the average Pupil-teacher ratio(headcount basis) of Mexico per year?
Offer a very short reply. 31.04. What is the average Pupil-teacher ratio(headcount basis) of Uganda per year?
Provide a succinct answer. 30.25. In the year 1987, what is the difference between the Pupil-teacher ratio(headcount basis) of East Asia (all income levels) and Pupil-teacher ratio(headcount basis) of Mauritania?
Offer a terse response. -24.62. In the year 1987, what is the difference between the Pupil-teacher ratio(headcount basis) in East Asia (all income levels) and Pupil-teacher ratio(headcount basis) in Mexico?
Your answer should be very brief. -7.61. In the year 1987, what is the difference between the Pupil-teacher ratio(headcount basis) of East Asia (all income levels) and Pupil-teacher ratio(headcount basis) of Uganda?
Your answer should be very brief. -6.44. In the year 1987, what is the difference between the Pupil-teacher ratio(headcount basis) in Mauritania and Pupil-teacher ratio(headcount basis) in Mexico?
Make the answer very short. 17. In the year 1987, what is the difference between the Pupil-teacher ratio(headcount basis) in Mauritania and Pupil-teacher ratio(headcount basis) in Uganda?
Keep it short and to the point. 18.18. In the year 1987, what is the difference between the Pupil-teacher ratio(headcount basis) of Mexico and Pupil-teacher ratio(headcount basis) of Uganda?
Provide a succinct answer. 1.17. In the year 1988, what is the difference between the Pupil-teacher ratio(headcount basis) in East Asia (all income levels) and Pupil-teacher ratio(headcount basis) in Mauritania?
Ensure brevity in your answer.  -25.08. In the year 1988, what is the difference between the Pupil-teacher ratio(headcount basis) in East Asia (all income levels) and Pupil-teacher ratio(headcount basis) in Mexico?
Make the answer very short. -7.27. In the year 1988, what is the difference between the Pupil-teacher ratio(headcount basis) in East Asia (all income levels) and Pupil-teacher ratio(headcount basis) in Uganda?
Keep it short and to the point. -7.37. In the year 1988, what is the difference between the Pupil-teacher ratio(headcount basis) in Mauritania and Pupil-teacher ratio(headcount basis) in Mexico?
Make the answer very short. 17.81. In the year 1988, what is the difference between the Pupil-teacher ratio(headcount basis) of Mauritania and Pupil-teacher ratio(headcount basis) of Uganda?
Provide a succinct answer. 17.71. In the year 1988, what is the difference between the Pupil-teacher ratio(headcount basis) in Mexico and Pupil-teacher ratio(headcount basis) in Uganda?
Ensure brevity in your answer.  -0.1. In the year 1989, what is the difference between the Pupil-teacher ratio(headcount basis) in East Asia (all income levels) and Pupil-teacher ratio(headcount basis) in Mauritania?
Offer a very short reply. -24.75. In the year 1989, what is the difference between the Pupil-teacher ratio(headcount basis) of East Asia (all income levels) and Pupil-teacher ratio(headcount basis) of Mexico?
Ensure brevity in your answer.  -7.26. In the year 1989, what is the difference between the Pupil-teacher ratio(headcount basis) of East Asia (all income levels) and Pupil-teacher ratio(headcount basis) of Uganda?
Provide a succinct answer. -5.02. In the year 1989, what is the difference between the Pupil-teacher ratio(headcount basis) in Mauritania and Pupil-teacher ratio(headcount basis) in Mexico?
Give a very brief answer. 17.49. In the year 1989, what is the difference between the Pupil-teacher ratio(headcount basis) in Mauritania and Pupil-teacher ratio(headcount basis) in Uganda?
Offer a very short reply. 19.73. In the year 1989, what is the difference between the Pupil-teacher ratio(headcount basis) in Mexico and Pupil-teacher ratio(headcount basis) in Uganda?
Ensure brevity in your answer.  2.25. In the year 1990, what is the difference between the Pupil-teacher ratio(headcount basis) of East Asia (all income levels) and Pupil-teacher ratio(headcount basis) of Mauritania?
Your answer should be very brief. -20.79. In the year 1990, what is the difference between the Pupil-teacher ratio(headcount basis) in East Asia (all income levels) and Pupil-teacher ratio(headcount basis) in Mexico?
Your answer should be compact. -7.5. In the year 1990, what is the difference between the Pupil-teacher ratio(headcount basis) in East Asia (all income levels) and Pupil-teacher ratio(headcount basis) in Uganda?
Offer a terse response. -5.79. In the year 1990, what is the difference between the Pupil-teacher ratio(headcount basis) of Mauritania and Pupil-teacher ratio(headcount basis) of Mexico?
Your answer should be very brief. 13.29. In the year 1990, what is the difference between the Pupil-teacher ratio(headcount basis) in Mauritania and Pupil-teacher ratio(headcount basis) in Uganda?
Give a very brief answer. 15. In the year 1990, what is the difference between the Pupil-teacher ratio(headcount basis) in Mexico and Pupil-teacher ratio(headcount basis) in Uganda?
Offer a very short reply. 1.71. In the year 1991, what is the difference between the Pupil-teacher ratio(headcount basis) in East Asia (all income levels) and Pupil-teacher ratio(headcount basis) in Mauritania?
Your answer should be very brief. -21.27. In the year 1991, what is the difference between the Pupil-teacher ratio(headcount basis) in East Asia (all income levels) and Pupil-teacher ratio(headcount basis) in Mexico?
Keep it short and to the point. -7.11. In the year 1991, what is the difference between the Pupil-teacher ratio(headcount basis) in East Asia (all income levels) and Pupil-teacher ratio(headcount basis) in Uganda?
Offer a terse response. -9.5. In the year 1991, what is the difference between the Pupil-teacher ratio(headcount basis) in Mauritania and Pupil-teacher ratio(headcount basis) in Mexico?
Make the answer very short. 14.17. In the year 1991, what is the difference between the Pupil-teacher ratio(headcount basis) of Mauritania and Pupil-teacher ratio(headcount basis) of Uganda?
Provide a short and direct response. 11.78. In the year 1991, what is the difference between the Pupil-teacher ratio(headcount basis) in Mexico and Pupil-teacher ratio(headcount basis) in Uganda?
Ensure brevity in your answer.  -2.39. In the year 1992, what is the difference between the Pupil-teacher ratio(headcount basis) in East Asia (all income levels) and Pupil-teacher ratio(headcount basis) in Mauritania?
Keep it short and to the point. -23.23. In the year 1992, what is the difference between the Pupil-teacher ratio(headcount basis) in East Asia (all income levels) and Pupil-teacher ratio(headcount basis) in Mexico?
Provide a succinct answer. -6.55. In the year 1992, what is the difference between the Pupil-teacher ratio(headcount basis) in East Asia (all income levels) and Pupil-teacher ratio(headcount basis) in Uganda?
Make the answer very short. -4.22. In the year 1992, what is the difference between the Pupil-teacher ratio(headcount basis) of Mauritania and Pupil-teacher ratio(headcount basis) of Mexico?
Ensure brevity in your answer.  16.67. In the year 1992, what is the difference between the Pupil-teacher ratio(headcount basis) in Mauritania and Pupil-teacher ratio(headcount basis) in Uganda?
Your response must be concise. 19. In the year 1992, what is the difference between the Pupil-teacher ratio(headcount basis) in Mexico and Pupil-teacher ratio(headcount basis) in Uganda?
Provide a short and direct response. 2.33. In the year 1993, what is the difference between the Pupil-teacher ratio(headcount basis) of East Asia (all income levels) and Pupil-teacher ratio(headcount basis) of Mauritania?
Provide a succinct answer. -27.76. In the year 1993, what is the difference between the Pupil-teacher ratio(headcount basis) in East Asia (all income levels) and Pupil-teacher ratio(headcount basis) in Mexico?
Your answer should be very brief. -6.13. In the year 1993, what is the difference between the Pupil-teacher ratio(headcount basis) of East Asia (all income levels) and Pupil-teacher ratio(headcount basis) of Uganda?
Ensure brevity in your answer.  -5.59. In the year 1993, what is the difference between the Pupil-teacher ratio(headcount basis) in Mauritania and Pupil-teacher ratio(headcount basis) in Mexico?
Give a very brief answer. 21.64. In the year 1993, what is the difference between the Pupil-teacher ratio(headcount basis) in Mauritania and Pupil-teacher ratio(headcount basis) in Uganda?
Give a very brief answer. 22.17. In the year 1993, what is the difference between the Pupil-teacher ratio(headcount basis) in Mexico and Pupil-teacher ratio(headcount basis) in Uganda?
Give a very brief answer. 0.53. What is the ratio of the Pupil-teacher ratio(headcount basis) of East Asia (all income levels) in 1987 to that in 1988?
Provide a succinct answer. 1.02. What is the ratio of the Pupil-teacher ratio(headcount basis) of Mauritania in 1987 to that in 1988?
Provide a short and direct response. 1. What is the ratio of the Pupil-teacher ratio(headcount basis) of Mexico in 1987 to that in 1988?
Make the answer very short. 1.03. What is the ratio of the Pupil-teacher ratio(headcount basis) in Uganda in 1987 to that in 1988?
Keep it short and to the point. 0.99. What is the ratio of the Pupil-teacher ratio(headcount basis) of East Asia (all income levels) in 1987 to that in 1989?
Provide a succinct answer. 1.05. What is the ratio of the Pupil-teacher ratio(headcount basis) in Mauritania in 1987 to that in 1989?
Your answer should be very brief. 1.02. What is the ratio of the Pupil-teacher ratio(headcount basis) in Mexico in 1987 to that in 1989?
Ensure brevity in your answer.  1.05. What is the ratio of the Pupil-teacher ratio(headcount basis) in Uganda in 1987 to that in 1989?
Your answer should be very brief. 1.09. What is the ratio of the Pupil-teacher ratio(headcount basis) in East Asia (all income levels) in 1987 to that in 1990?
Your answer should be compact. 1.07. What is the ratio of the Pupil-teacher ratio(headcount basis) of Mauritania in 1987 to that in 1990?
Offer a very short reply. 1.12. What is the ratio of the Pupil-teacher ratio(headcount basis) in Mexico in 1987 to that in 1990?
Your answer should be compact. 1.06. What is the ratio of the Pupil-teacher ratio(headcount basis) in Uganda in 1987 to that in 1990?
Your answer should be compact. 1.08. What is the ratio of the Pupil-teacher ratio(headcount basis) in East Asia (all income levels) in 1987 to that in 1991?
Provide a short and direct response. 1.08. What is the ratio of the Pupil-teacher ratio(headcount basis) of Mauritania in 1987 to that in 1991?
Your answer should be compact. 1.11. What is the ratio of the Pupil-teacher ratio(headcount basis) in Mexico in 1987 to that in 1991?
Your answer should be compact. 1.07. What is the ratio of the Pupil-teacher ratio(headcount basis) of Uganda in 1987 to that in 1991?
Your response must be concise. 0.96. What is the ratio of the Pupil-teacher ratio(headcount basis) in East Asia (all income levels) in 1987 to that in 1992?
Your response must be concise. 1.07. What is the ratio of the Pupil-teacher ratio(headcount basis) in Mauritania in 1987 to that in 1992?
Provide a short and direct response. 1.07. What is the ratio of the Pupil-teacher ratio(headcount basis) of Mexico in 1987 to that in 1992?
Keep it short and to the point. 1.09. What is the ratio of the Pupil-teacher ratio(headcount basis) of Uganda in 1987 to that in 1992?
Provide a succinct answer. 1.14. What is the ratio of the Pupil-teacher ratio(headcount basis) in East Asia (all income levels) in 1987 to that in 1993?
Offer a very short reply. 1.07. What is the ratio of the Pupil-teacher ratio(headcount basis) in Mauritania in 1987 to that in 1993?
Make the answer very short. 0.97. What is the ratio of the Pupil-teacher ratio(headcount basis) of Mexico in 1987 to that in 1993?
Offer a terse response. 1.11. What is the ratio of the Pupil-teacher ratio(headcount basis) in Uganda in 1987 to that in 1993?
Your answer should be compact. 1.09. What is the ratio of the Pupil-teacher ratio(headcount basis) of East Asia (all income levels) in 1988 to that in 1989?
Make the answer very short. 1.02. What is the ratio of the Pupil-teacher ratio(headcount basis) of Mauritania in 1988 to that in 1989?
Make the answer very short. 1.02. What is the ratio of the Pupil-teacher ratio(headcount basis) in Mexico in 1988 to that in 1989?
Your answer should be compact. 1.02. What is the ratio of the Pupil-teacher ratio(headcount basis) in Uganda in 1988 to that in 1989?
Provide a succinct answer. 1.1. What is the ratio of the Pupil-teacher ratio(headcount basis) in East Asia (all income levels) in 1988 to that in 1990?
Your answer should be compact. 1.04. What is the ratio of the Pupil-teacher ratio(headcount basis) in Mauritania in 1988 to that in 1990?
Offer a terse response. 1.12. What is the ratio of the Pupil-teacher ratio(headcount basis) of Mexico in 1988 to that in 1990?
Your answer should be compact. 1.03. What is the ratio of the Pupil-teacher ratio(headcount basis) in Uganda in 1988 to that in 1990?
Keep it short and to the point. 1.09. What is the ratio of the Pupil-teacher ratio(headcount basis) of East Asia (all income levels) in 1988 to that in 1991?
Keep it short and to the point. 1.05. What is the ratio of the Pupil-teacher ratio(headcount basis) of Mauritania in 1988 to that in 1991?
Your response must be concise. 1.11. What is the ratio of the Pupil-teacher ratio(headcount basis) in Mexico in 1988 to that in 1991?
Offer a very short reply. 1.04. What is the ratio of the Pupil-teacher ratio(headcount basis) of Uganda in 1988 to that in 1991?
Offer a very short reply. 0.97. What is the ratio of the Pupil-teacher ratio(headcount basis) in East Asia (all income levels) in 1988 to that in 1992?
Your response must be concise. 1.05. What is the ratio of the Pupil-teacher ratio(headcount basis) in Mauritania in 1988 to that in 1992?
Ensure brevity in your answer.  1.06. What is the ratio of the Pupil-teacher ratio(headcount basis) of Mexico in 1988 to that in 1992?
Make the answer very short. 1.06. What is the ratio of the Pupil-teacher ratio(headcount basis) in Uganda in 1988 to that in 1992?
Provide a short and direct response. 1.16. What is the ratio of the Pupil-teacher ratio(headcount basis) in East Asia (all income levels) in 1988 to that in 1993?
Your response must be concise. 1.05. What is the ratio of the Pupil-teacher ratio(headcount basis) in Mauritania in 1988 to that in 1993?
Provide a succinct answer. 0.97. What is the ratio of the Pupil-teacher ratio(headcount basis) of Mexico in 1988 to that in 1993?
Keep it short and to the point. 1.08. What is the ratio of the Pupil-teacher ratio(headcount basis) in Uganda in 1988 to that in 1993?
Provide a short and direct response. 1.1. What is the ratio of the Pupil-teacher ratio(headcount basis) in East Asia (all income levels) in 1989 to that in 1990?
Your answer should be very brief. 1.02. What is the ratio of the Pupil-teacher ratio(headcount basis) of Mauritania in 1989 to that in 1990?
Offer a terse response. 1.1. What is the ratio of the Pupil-teacher ratio(headcount basis) in Uganda in 1989 to that in 1990?
Offer a terse response. 0.99. What is the ratio of the Pupil-teacher ratio(headcount basis) of East Asia (all income levels) in 1989 to that in 1991?
Offer a very short reply. 1.03. What is the ratio of the Pupil-teacher ratio(headcount basis) in Mauritania in 1989 to that in 1991?
Your answer should be compact. 1.09. What is the ratio of the Pupil-teacher ratio(headcount basis) of Mexico in 1989 to that in 1991?
Provide a short and direct response. 1.03. What is the ratio of the Pupil-teacher ratio(headcount basis) of Uganda in 1989 to that in 1991?
Make the answer very short. 0.88. What is the ratio of the Pupil-teacher ratio(headcount basis) in East Asia (all income levels) in 1989 to that in 1992?
Your answer should be very brief. 1.02. What is the ratio of the Pupil-teacher ratio(headcount basis) in Mauritania in 1989 to that in 1992?
Ensure brevity in your answer.  1.05. What is the ratio of the Pupil-teacher ratio(headcount basis) of Mexico in 1989 to that in 1992?
Offer a very short reply. 1.04. What is the ratio of the Pupil-teacher ratio(headcount basis) of Uganda in 1989 to that in 1992?
Your response must be concise. 1.05. What is the ratio of the Pupil-teacher ratio(headcount basis) in East Asia (all income levels) in 1989 to that in 1993?
Ensure brevity in your answer.  1.02. What is the ratio of the Pupil-teacher ratio(headcount basis) of Mauritania in 1989 to that in 1993?
Provide a short and direct response. 0.95. What is the ratio of the Pupil-teacher ratio(headcount basis) in Mexico in 1989 to that in 1993?
Your answer should be compact. 1.06. What is the ratio of the Pupil-teacher ratio(headcount basis) in Uganda in 1989 to that in 1993?
Your answer should be very brief. 1. What is the ratio of the Pupil-teacher ratio(headcount basis) in East Asia (all income levels) in 1990 to that in 1991?
Your answer should be very brief. 1.01. What is the ratio of the Pupil-teacher ratio(headcount basis) of Mexico in 1990 to that in 1991?
Your response must be concise. 1.02. What is the ratio of the Pupil-teacher ratio(headcount basis) in Uganda in 1990 to that in 1991?
Your answer should be very brief. 0.89. What is the ratio of the Pupil-teacher ratio(headcount basis) of Mauritania in 1990 to that in 1992?
Make the answer very short. 0.95. What is the ratio of the Pupil-teacher ratio(headcount basis) in Mexico in 1990 to that in 1992?
Offer a terse response. 1.03. What is the ratio of the Pupil-teacher ratio(headcount basis) of Uganda in 1990 to that in 1992?
Make the answer very short. 1.06. What is the ratio of the Pupil-teacher ratio(headcount basis) of Mauritania in 1990 to that in 1993?
Keep it short and to the point. 0.87. What is the ratio of the Pupil-teacher ratio(headcount basis) of Mexico in 1990 to that in 1993?
Your answer should be compact. 1.05. What is the ratio of the Pupil-teacher ratio(headcount basis) of Uganda in 1990 to that in 1993?
Your response must be concise. 1.01. What is the ratio of the Pupil-teacher ratio(headcount basis) in Mauritania in 1991 to that in 1992?
Offer a very short reply. 0.96. What is the ratio of the Pupil-teacher ratio(headcount basis) in Mexico in 1991 to that in 1992?
Your answer should be very brief. 1.02. What is the ratio of the Pupil-teacher ratio(headcount basis) of Uganda in 1991 to that in 1992?
Your response must be concise. 1.19. What is the ratio of the Pupil-teacher ratio(headcount basis) of Mauritania in 1991 to that in 1993?
Your response must be concise. 0.87. What is the ratio of the Pupil-teacher ratio(headcount basis) in Mexico in 1991 to that in 1993?
Make the answer very short. 1.03. What is the ratio of the Pupil-teacher ratio(headcount basis) in Uganda in 1991 to that in 1993?
Your answer should be compact. 1.13. What is the ratio of the Pupil-teacher ratio(headcount basis) of Mauritania in 1992 to that in 1993?
Give a very brief answer. 0.91. What is the ratio of the Pupil-teacher ratio(headcount basis) of Mexico in 1992 to that in 1993?
Your answer should be very brief. 1.01. What is the ratio of the Pupil-teacher ratio(headcount basis) in Uganda in 1992 to that in 1993?
Your response must be concise. 0.95. What is the difference between the highest and the second highest Pupil-teacher ratio(headcount basis) in East Asia (all income levels)?
Ensure brevity in your answer.  0.59. What is the difference between the highest and the second highest Pupil-teacher ratio(headcount basis) in Mauritania?
Ensure brevity in your answer.  1.46. What is the difference between the highest and the second highest Pupil-teacher ratio(headcount basis) in Mexico?
Your answer should be compact. 0.93. What is the difference between the highest and the second highest Pupil-teacher ratio(headcount basis) of Uganda?
Offer a terse response. 0.94. What is the difference between the highest and the lowest Pupil-teacher ratio(headcount basis) in East Asia (all income levels)?
Offer a very short reply. 1.77. What is the difference between the highest and the lowest Pupil-teacher ratio(headcount basis) of Mauritania?
Provide a succinct answer. 6.92. What is the difference between the highest and the lowest Pupil-teacher ratio(headcount basis) in Mexico?
Your answer should be compact. 3.18. What is the difference between the highest and the lowest Pupil-teacher ratio(headcount basis) of Uganda?
Your answer should be very brief. 5.24. 